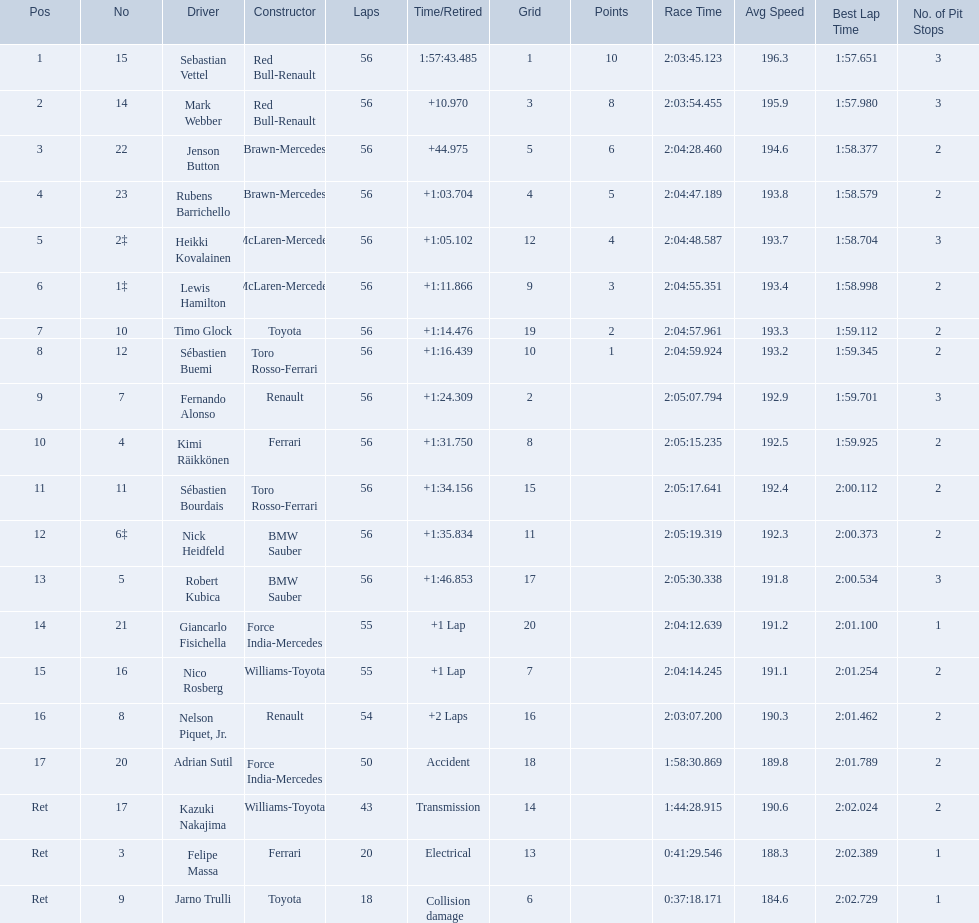Which drive retired because of electrical issues? Felipe Massa. Which driver retired due to accident? Adrian Sutil. Which driver retired due to collision damage? Jarno Trulli. 